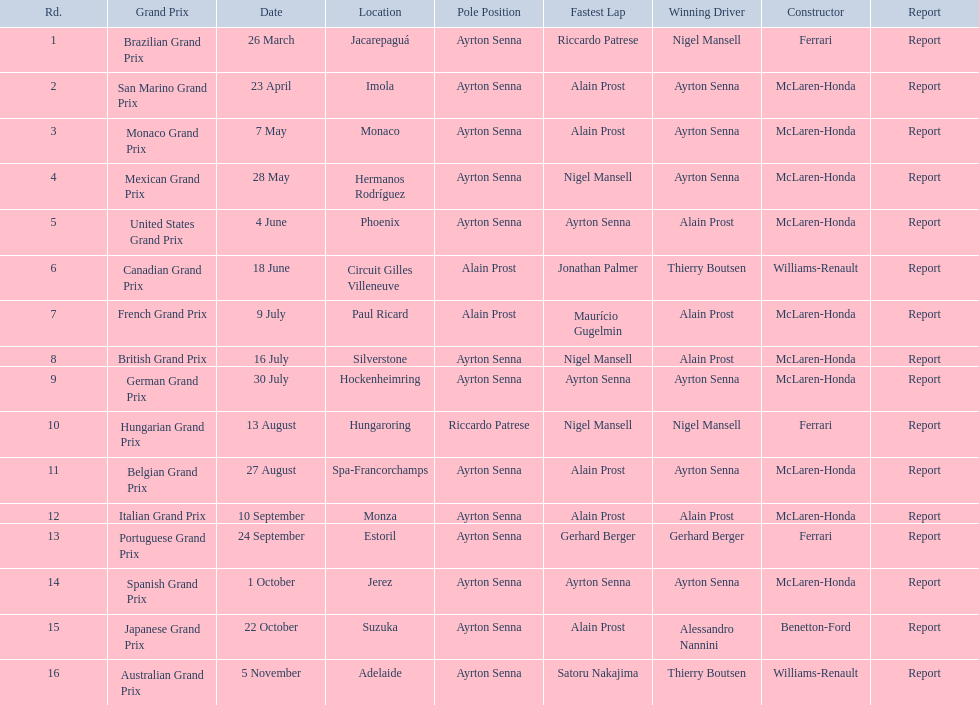Who had the fastest lap at the german grand prix? Ayrton Senna. 